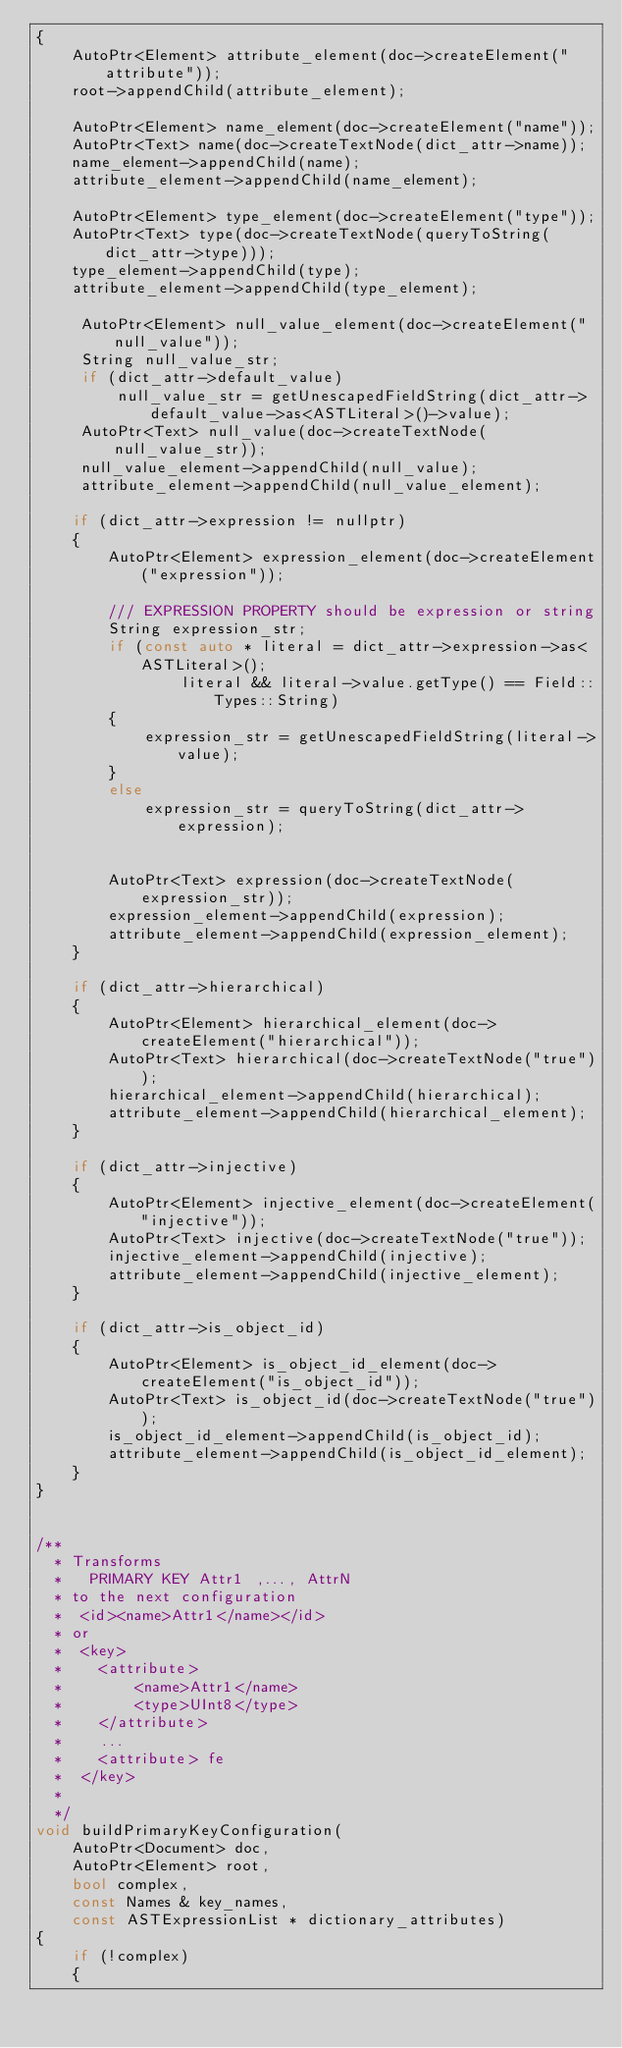Convert code to text. <code><loc_0><loc_0><loc_500><loc_500><_C++_>{
    AutoPtr<Element> attribute_element(doc->createElement("attribute"));
    root->appendChild(attribute_element);

    AutoPtr<Element> name_element(doc->createElement("name"));
    AutoPtr<Text> name(doc->createTextNode(dict_attr->name));
    name_element->appendChild(name);
    attribute_element->appendChild(name_element);

    AutoPtr<Element> type_element(doc->createElement("type"));
    AutoPtr<Text> type(doc->createTextNode(queryToString(dict_attr->type)));
    type_element->appendChild(type);
    attribute_element->appendChild(type_element);

     AutoPtr<Element> null_value_element(doc->createElement("null_value"));
     String null_value_str;
     if (dict_attr->default_value)
         null_value_str = getUnescapedFieldString(dict_attr->default_value->as<ASTLiteral>()->value);
     AutoPtr<Text> null_value(doc->createTextNode(null_value_str));
     null_value_element->appendChild(null_value);
     attribute_element->appendChild(null_value_element);

    if (dict_attr->expression != nullptr)
    {
        AutoPtr<Element> expression_element(doc->createElement("expression"));

        /// EXPRESSION PROPERTY should be expression or string
        String expression_str;
        if (const auto * literal = dict_attr->expression->as<ASTLiteral>();
                literal && literal->value.getType() == Field::Types::String)
        {
            expression_str = getUnescapedFieldString(literal->value);
        }
        else
            expression_str = queryToString(dict_attr->expression);


        AutoPtr<Text> expression(doc->createTextNode(expression_str));
        expression_element->appendChild(expression);
        attribute_element->appendChild(expression_element);
    }

    if (dict_attr->hierarchical)
    {
        AutoPtr<Element> hierarchical_element(doc->createElement("hierarchical"));
        AutoPtr<Text> hierarchical(doc->createTextNode("true"));
        hierarchical_element->appendChild(hierarchical);
        attribute_element->appendChild(hierarchical_element);
    }

    if (dict_attr->injective)
    {
        AutoPtr<Element> injective_element(doc->createElement("injective"));
        AutoPtr<Text> injective(doc->createTextNode("true"));
        injective_element->appendChild(injective);
        attribute_element->appendChild(injective_element);
    }

    if (dict_attr->is_object_id)
    {
        AutoPtr<Element> is_object_id_element(doc->createElement("is_object_id"));
        AutoPtr<Text> is_object_id(doc->createTextNode("true"));
        is_object_id_element->appendChild(is_object_id);
        attribute_element->appendChild(is_object_id_element);
    }
}


/**
  * Transforms
  *   PRIMARY KEY Attr1 ,..., AttrN
  * to the next configuration
  *  <id><name>Attr1</name></id>
  * or
  *  <key>
  *    <attribute>
  *        <name>Attr1</name>
  *        <type>UInt8</type>
  *    </attribute>
  *    ...
  *    <attribute> fe
  *  </key>
  *
  */
void buildPrimaryKeyConfiguration(
    AutoPtr<Document> doc,
    AutoPtr<Element> root,
    bool complex,
    const Names & key_names,
    const ASTExpressionList * dictionary_attributes)
{
    if (!complex)
    {</code> 